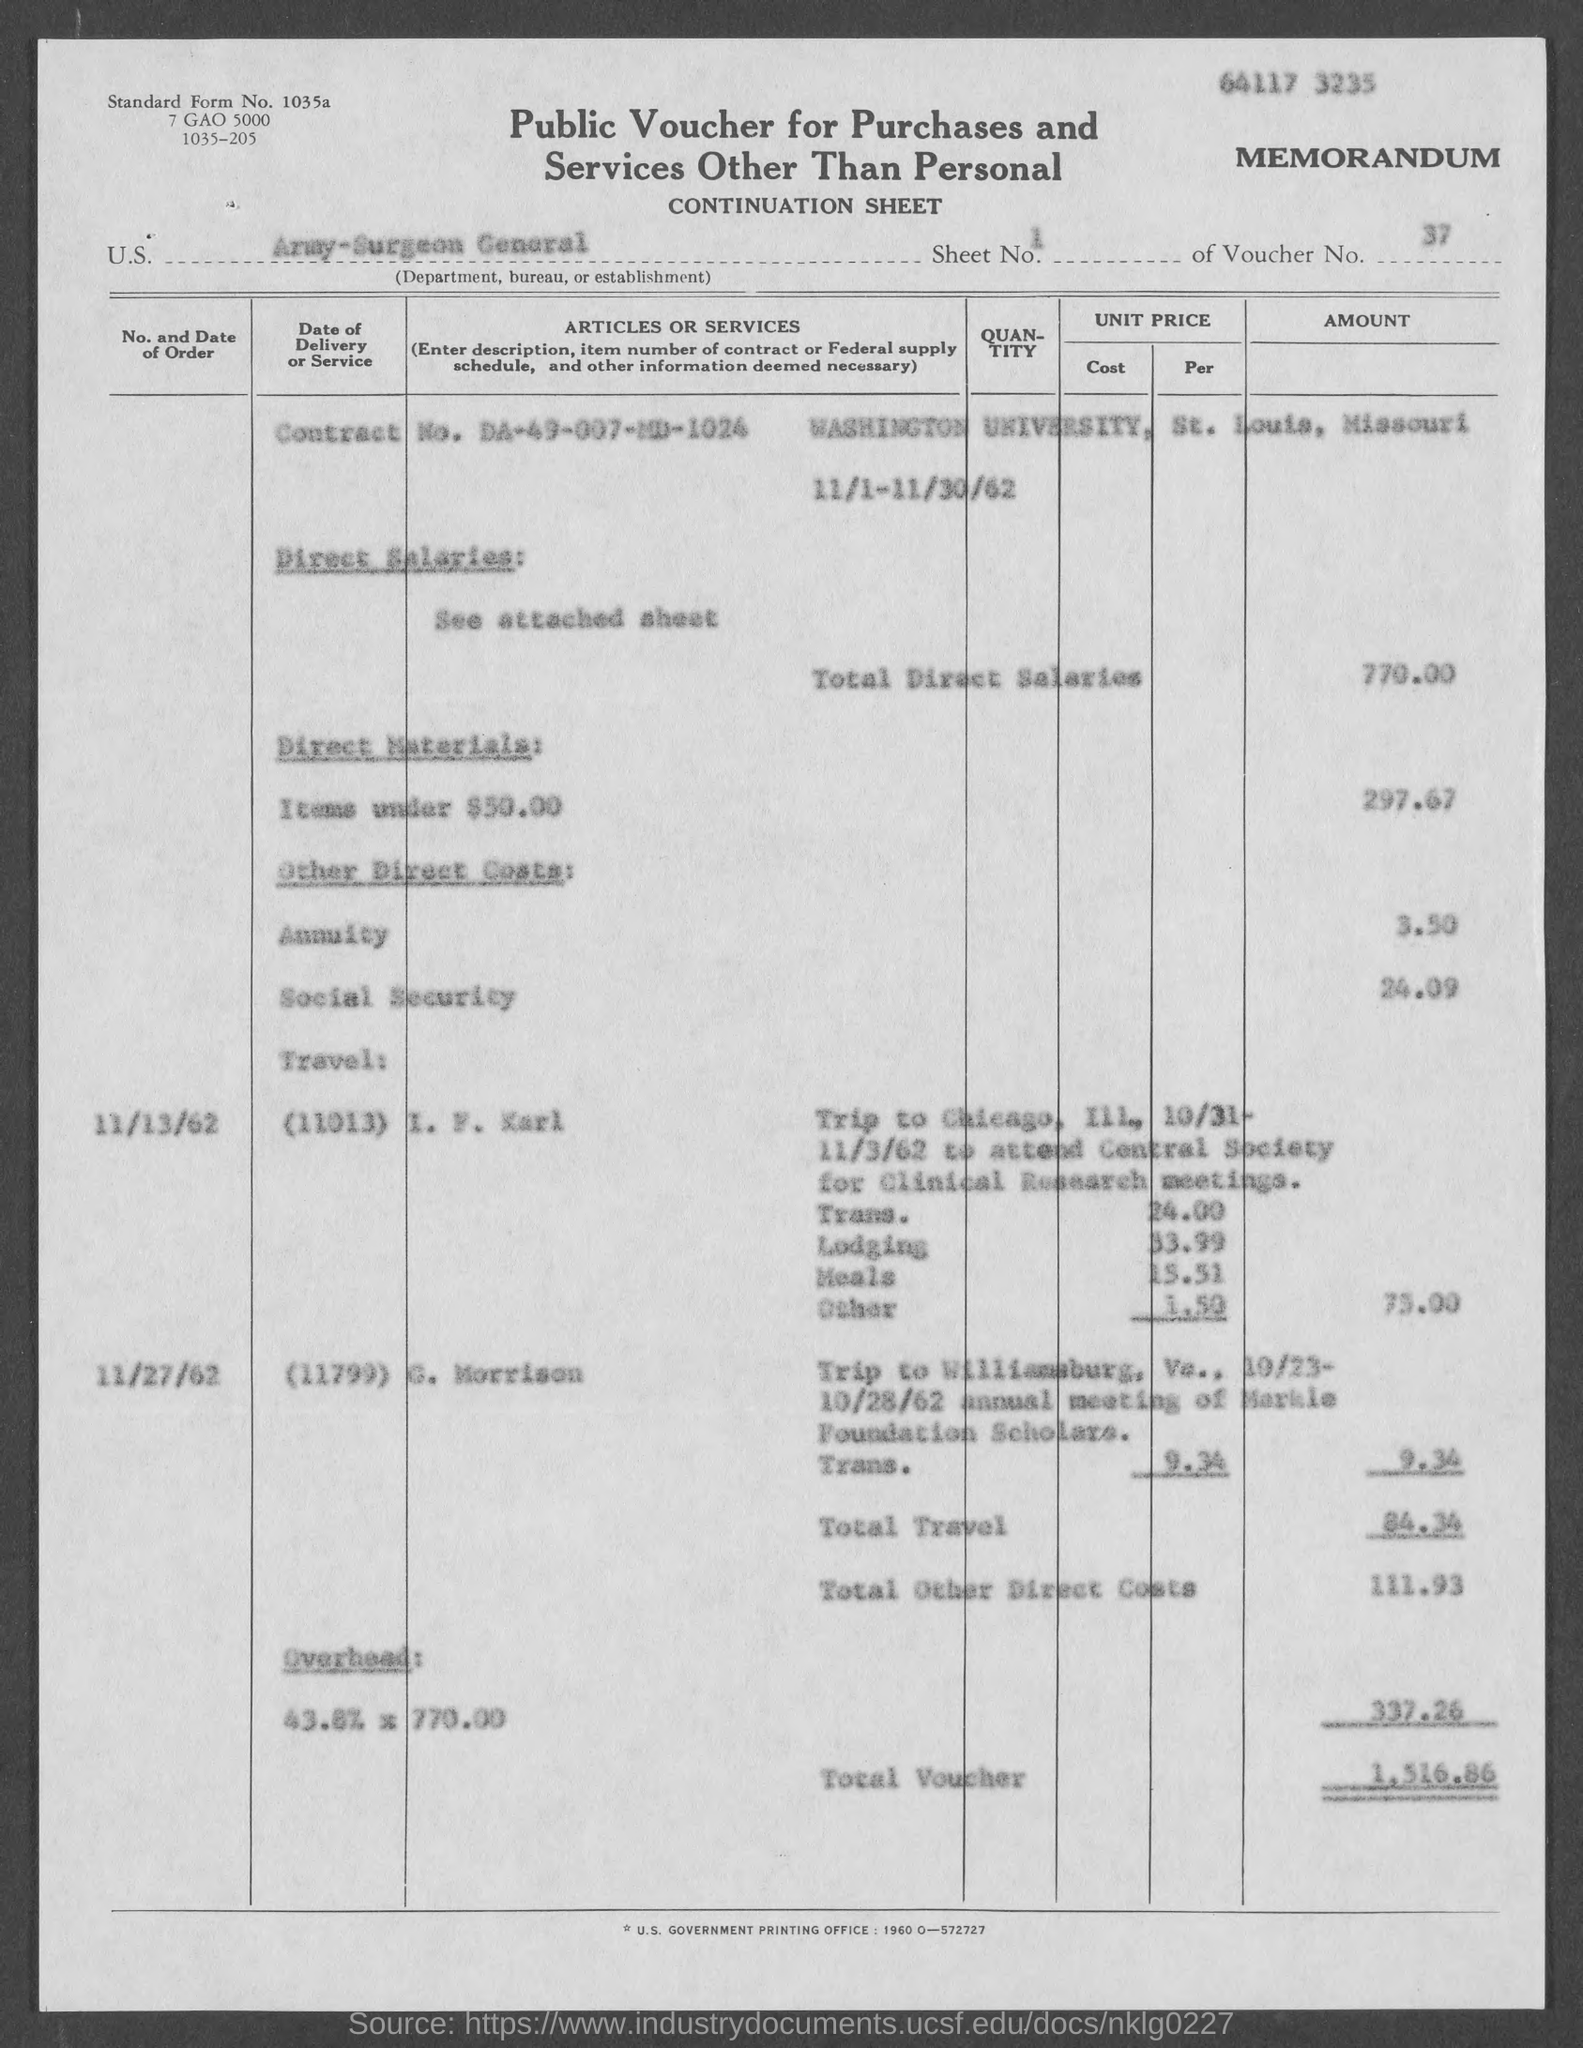Please describe what this document is. This is a 'Public Voucher for Purchases and Services Other Than Personal' form. It's a continuation sheet used by the U.S. Army Surgeon General to record various expenses such as direct salaries, materials, travel, and overhead costs. 